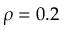<formula> <loc_0><loc_0><loc_500><loc_500>\rho = 0 . 2</formula> 